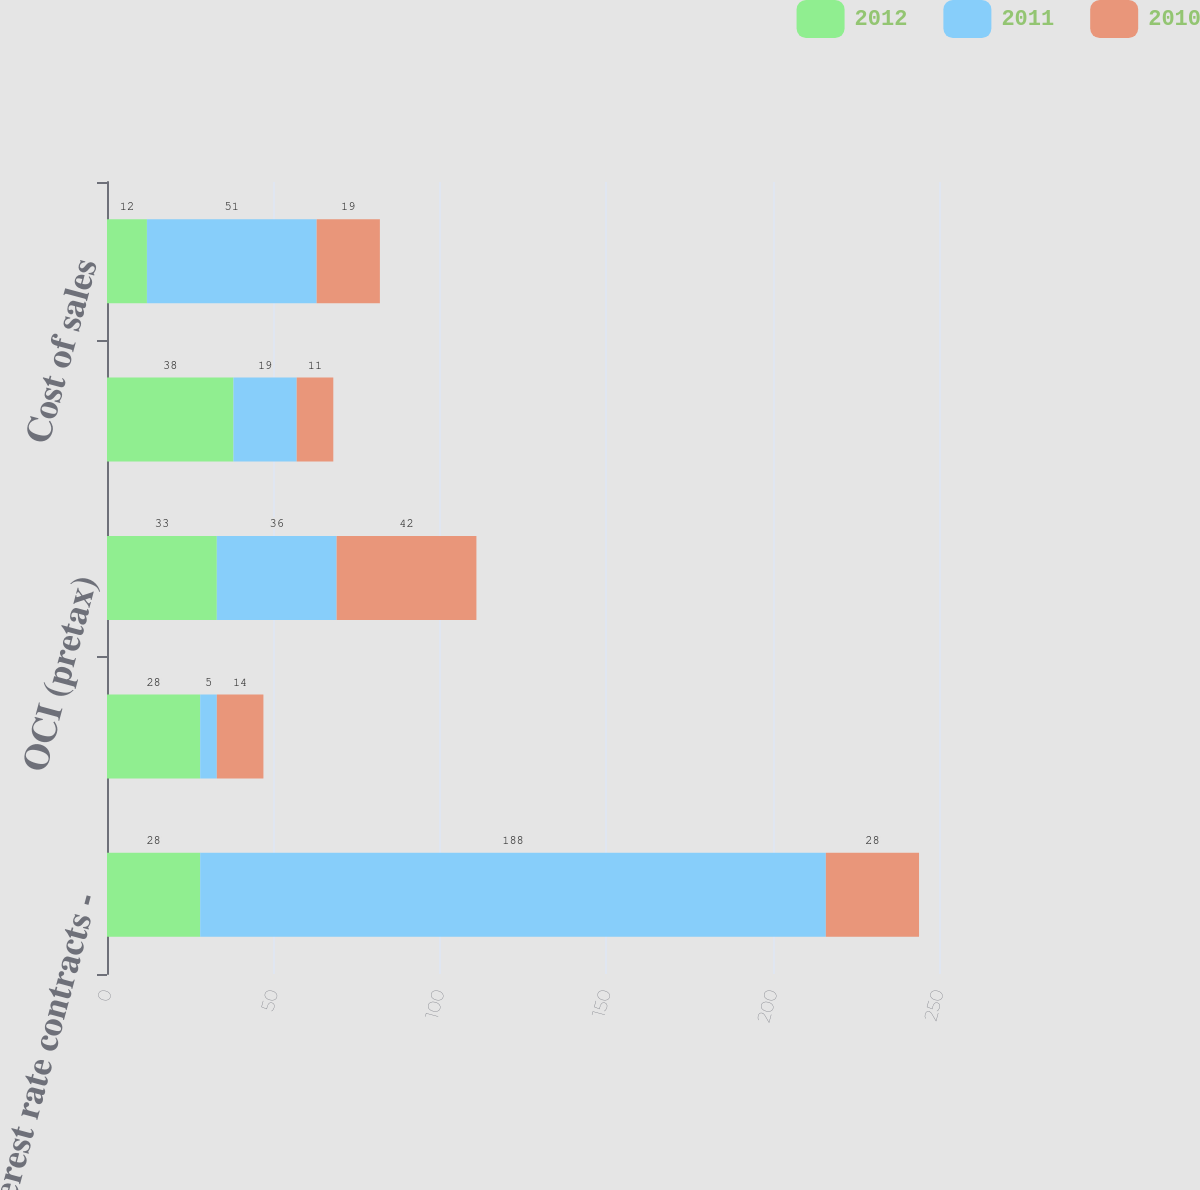<chart> <loc_0><loc_0><loc_500><loc_500><stacked_bar_chart><ecel><fcel>Interest rate contracts -<fcel>Interest rate contracts - OCI<fcel>OCI (pretax)<fcel>Other expense<fcel>Cost of sales<nl><fcel>2012<fcel>28<fcel>28<fcel>33<fcel>38<fcel>12<nl><fcel>2011<fcel>188<fcel>5<fcel>36<fcel>19<fcel>51<nl><fcel>2010<fcel>28<fcel>14<fcel>42<fcel>11<fcel>19<nl></chart> 